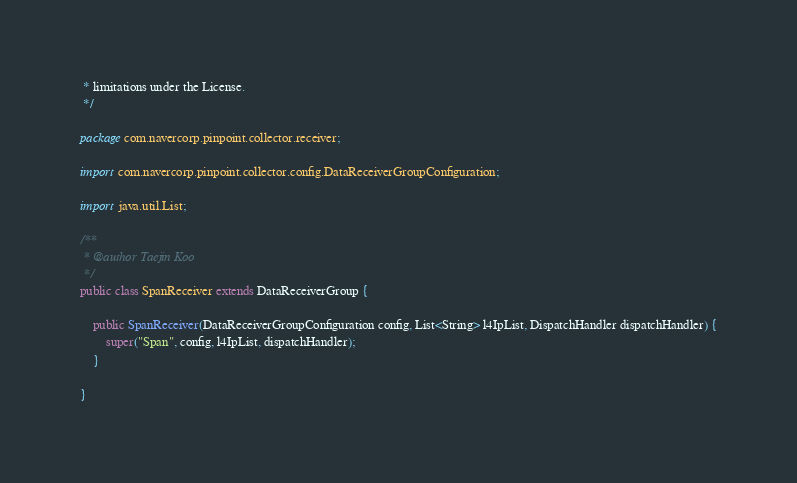Convert code to text. <code><loc_0><loc_0><loc_500><loc_500><_Java_> * limitations under the License.
 */

package com.navercorp.pinpoint.collector.receiver;

import com.navercorp.pinpoint.collector.config.DataReceiverGroupConfiguration;

import java.util.List;

/**
 * @author Taejin Koo
 */
public class SpanReceiver extends DataReceiverGroup {

    public SpanReceiver(DataReceiverGroupConfiguration config, List<String> l4IpList, DispatchHandler dispatchHandler) {
        super("Span", config, l4IpList, dispatchHandler);
    }

}
</code> 